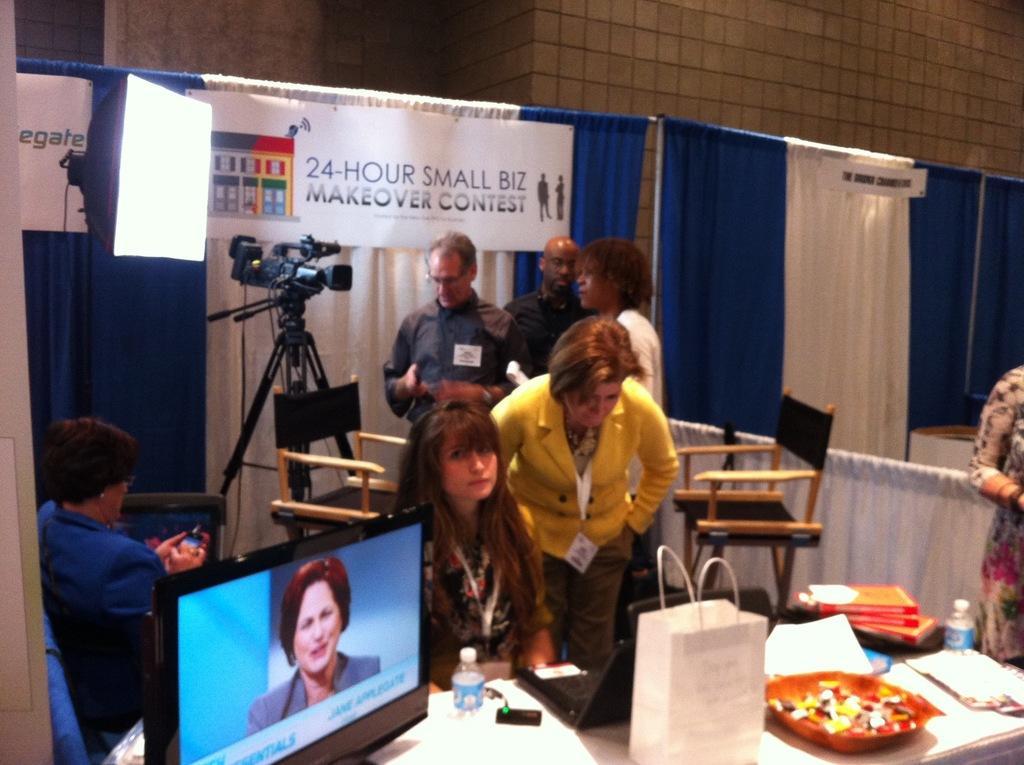Could you give a brief overview of what you see in this image? In this image we can see some people on the floor, one woman is looking into a laptop. We can also see a television, a bottle, bag, plate, paper, books and pad on the table. On the backside we can see a woman sitting on the chair holding a cellphone. We can also see a light, camera with stand, three people standing, a wall and the curtains. 